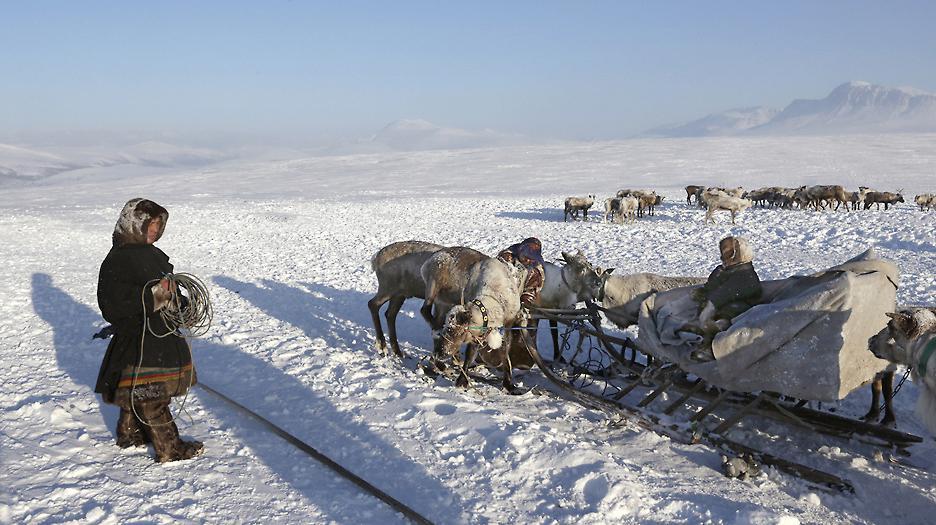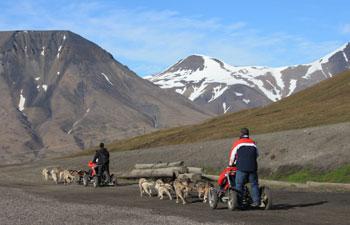The first image is the image on the left, the second image is the image on the right. Given the left and right images, does the statement "There are sled dogs laying in the snow." hold true? Answer yes or no. No. The first image is the image on the left, the second image is the image on the right. Assess this claim about the two images: "Neither image shows a team of animals that are moving across the ground, and both images show sled dog teams.". Correct or not? Answer yes or no. No. 